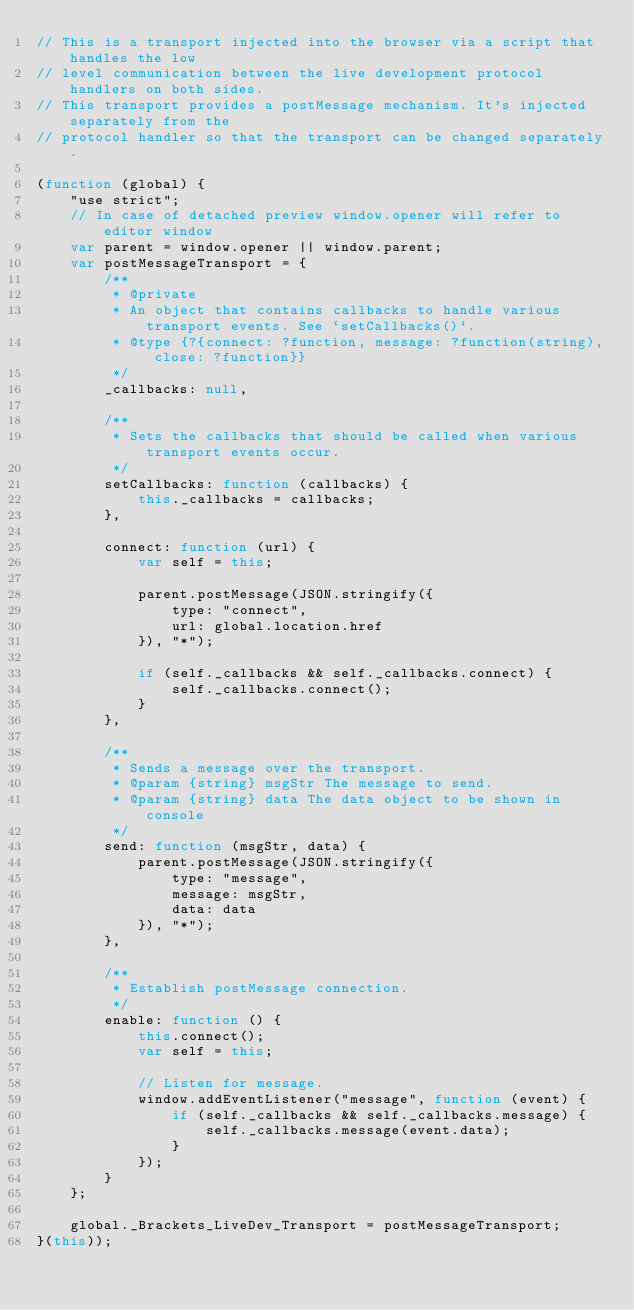<code> <loc_0><loc_0><loc_500><loc_500><_JavaScript_>// This is a transport injected into the browser via a script that handles the low
// level communication between the live development protocol handlers on both sides.
// This transport provides a postMessage mechanism. It's injected separately from the
// protocol handler so that the transport can be changed separately.

(function (global) {
    "use strict";
    // In case of detached preview window.opener will refer to editor window
    var parent = window.opener || window.parent;
    var postMessageTransport = {
        /**
         * @private
         * An object that contains callbacks to handle various transport events. See `setCallbacks()`.
         * @type {?{connect: ?function, message: ?function(string), close: ?function}}
         */
        _callbacks: null,

        /**
         * Sets the callbacks that should be called when various transport events occur.
         */
        setCallbacks: function (callbacks) {
            this._callbacks = callbacks;
        },

        connect: function (url) {
            var self = this;

            parent.postMessage(JSON.stringify({
                type: "connect",
                url: global.location.href
            }), "*");

            if (self._callbacks && self._callbacks.connect) {
                self._callbacks.connect();
            }
        },

        /**
         * Sends a message over the transport.
         * @param {string} msgStr The message to send.
         * @param {string} data The data object to be shown in console
         */
        send: function (msgStr, data) {
            parent.postMessage(JSON.stringify({
                type: "message",
                message: msgStr,
                data: data
            }), "*");
        },

        /**
         * Establish postMessage connection.
         */
        enable: function () {
            this.connect();
            var self = this;

            // Listen for message.
            window.addEventListener("message", function (event) {
                if (self._callbacks && self._callbacks.message) {
                    self._callbacks.message(event.data);
                }
            });
        }
    };

    global._Brackets_LiveDev_Transport = postMessageTransport;
}(this));
</code> 